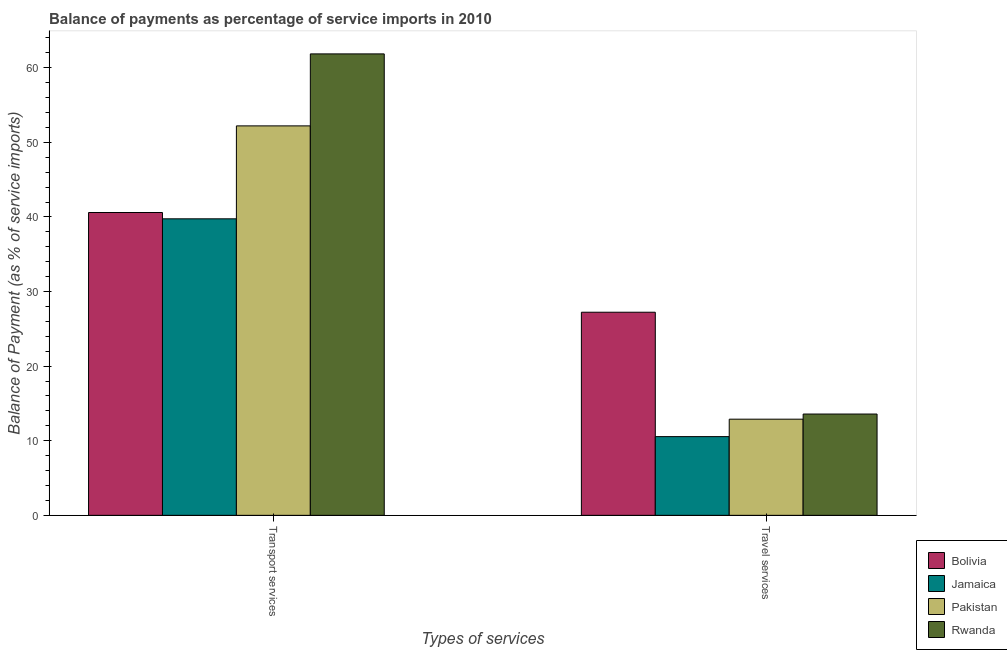Are the number of bars per tick equal to the number of legend labels?
Keep it short and to the point. Yes. How many bars are there on the 1st tick from the right?
Make the answer very short. 4. What is the label of the 2nd group of bars from the left?
Offer a terse response. Travel services. What is the balance of payments of transport services in Pakistan?
Your response must be concise. 52.21. Across all countries, what is the maximum balance of payments of travel services?
Give a very brief answer. 27.23. Across all countries, what is the minimum balance of payments of travel services?
Your response must be concise. 10.55. In which country was the balance of payments of transport services maximum?
Provide a succinct answer. Rwanda. In which country was the balance of payments of transport services minimum?
Ensure brevity in your answer.  Jamaica. What is the total balance of payments of travel services in the graph?
Your answer should be compact. 64.25. What is the difference between the balance of payments of transport services in Rwanda and that in Jamaica?
Keep it short and to the point. 22.11. What is the difference between the balance of payments of transport services in Pakistan and the balance of payments of travel services in Rwanda?
Keep it short and to the point. 38.63. What is the average balance of payments of transport services per country?
Offer a terse response. 48.6. What is the difference between the balance of payments of transport services and balance of payments of travel services in Bolivia?
Make the answer very short. 13.37. In how many countries, is the balance of payments of travel services greater than 2 %?
Your answer should be very brief. 4. What is the ratio of the balance of payments of transport services in Bolivia to that in Rwanda?
Keep it short and to the point. 0.66. In how many countries, is the balance of payments of transport services greater than the average balance of payments of transport services taken over all countries?
Your answer should be compact. 2. What does the 2nd bar from the left in Travel services represents?
Give a very brief answer. Jamaica. Are all the bars in the graph horizontal?
Keep it short and to the point. No. How many countries are there in the graph?
Your answer should be compact. 4. What is the difference between two consecutive major ticks on the Y-axis?
Your answer should be very brief. 10. Does the graph contain grids?
Your answer should be compact. No. Where does the legend appear in the graph?
Give a very brief answer. Bottom right. How many legend labels are there?
Give a very brief answer. 4. What is the title of the graph?
Give a very brief answer. Balance of payments as percentage of service imports in 2010. What is the label or title of the X-axis?
Offer a very short reply. Types of services. What is the label or title of the Y-axis?
Your answer should be compact. Balance of Payment (as % of service imports). What is the Balance of Payment (as % of service imports) in Bolivia in Transport services?
Ensure brevity in your answer.  40.6. What is the Balance of Payment (as % of service imports) in Jamaica in Transport services?
Offer a terse response. 39.75. What is the Balance of Payment (as % of service imports) of Pakistan in Transport services?
Give a very brief answer. 52.21. What is the Balance of Payment (as % of service imports) in Rwanda in Transport services?
Make the answer very short. 61.86. What is the Balance of Payment (as % of service imports) of Bolivia in Travel services?
Provide a short and direct response. 27.23. What is the Balance of Payment (as % of service imports) of Jamaica in Travel services?
Make the answer very short. 10.55. What is the Balance of Payment (as % of service imports) in Pakistan in Travel services?
Make the answer very short. 12.89. What is the Balance of Payment (as % of service imports) in Rwanda in Travel services?
Provide a succinct answer. 13.58. Across all Types of services, what is the maximum Balance of Payment (as % of service imports) of Bolivia?
Give a very brief answer. 40.6. Across all Types of services, what is the maximum Balance of Payment (as % of service imports) of Jamaica?
Give a very brief answer. 39.75. Across all Types of services, what is the maximum Balance of Payment (as % of service imports) in Pakistan?
Provide a short and direct response. 52.21. Across all Types of services, what is the maximum Balance of Payment (as % of service imports) in Rwanda?
Your answer should be very brief. 61.86. Across all Types of services, what is the minimum Balance of Payment (as % of service imports) of Bolivia?
Your answer should be very brief. 27.23. Across all Types of services, what is the minimum Balance of Payment (as % of service imports) in Jamaica?
Make the answer very short. 10.55. Across all Types of services, what is the minimum Balance of Payment (as % of service imports) of Pakistan?
Give a very brief answer. 12.89. Across all Types of services, what is the minimum Balance of Payment (as % of service imports) of Rwanda?
Your answer should be very brief. 13.58. What is the total Balance of Payment (as % of service imports) in Bolivia in the graph?
Give a very brief answer. 67.82. What is the total Balance of Payment (as % of service imports) of Jamaica in the graph?
Provide a short and direct response. 50.3. What is the total Balance of Payment (as % of service imports) of Pakistan in the graph?
Your response must be concise. 65.1. What is the total Balance of Payment (as % of service imports) in Rwanda in the graph?
Your answer should be compact. 75.44. What is the difference between the Balance of Payment (as % of service imports) in Bolivia in Transport services and that in Travel services?
Give a very brief answer. 13.37. What is the difference between the Balance of Payment (as % of service imports) in Jamaica in Transport services and that in Travel services?
Keep it short and to the point. 29.2. What is the difference between the Balance of Payment (as % of service imports) in Pakistan in Transport services and that in Travel services?
Offer a terse response. 39.32. What is the difference between the Balance of Payment (as % of service imports) of Rwanda in Transport services and that in Travel services?
Give a very brief answer. 48.28. What is the difference between the Balance of Payment (as % of service imports) of Bolivia in Transport services and the Balance of Payment (as % of service imports) of Jamaica in Travel services?
Offer a very short reply. 30.04. What is the difference between the Balance of Payment (as % of service imports) in Bolivia in Transport services and the Balance of Payment (as % of service imports) in Pakistan in Travel services?
Make the answer very short. 27.7. What is the difference between the Balance of Payment (as % of service imports) of Bolivia in Transport services and the Balance of Payment (as % of service imports) of Rwanda in Travel services?
Keep it short and to the point. 27.02. What is the difference between the Balance of Payment (as % of service imports) in Jamaica in Transport services and the Balance of Payment (as % of service imports) in Pakistan in Travel services?
Keep it short and to the point. 26.86. What is the difference between the Balance of Payment (as % of service imports) of Jamaica in Transport services and the Balance of Payment (as % of service imports) of Rwanda in Travel services?
Provide a short and direct response. 26.17. What is the difference between the Balance of Payment (as % of service imports) of Pakistan in Transport services and the Balance of Payment (as % of service imports) of Rwanda in Travel services?
Your response must be concise. 38.63. What is the average Balance of Payment (as % of service imports) in Bolivia per Types of services?
Offer a very short reply. 33.91. What is the average Balance of Payment (as % of service imports) in Jamaica per Types of services?
Provide a short and direct response. 25.15. What is the average Balance of Payment (as % of service imports) in Pakistan per Types of services?
Provide a short and direct response. 32.55. What is the average Balance of Payment (as % of service imports) in Rwanda per Types of services?
Keep it short and to the point. 37.72. What is the difference between the Balance of Payment (as % of service imports) of Bolivia and Balance of Payment (as % of service imports) of Jamaica in Transport services?
Offer a very short reply. 0.84. What is the difference between the Balance of Payment (as % of service imports) of Bolivia and Balance of Payment (as % of service imports) of Pakistan in Transport services?
Make the answer very short. -11.61. What is the difference between the Balance of Payment (as % of service imports) of Bolivia and Balance of Payment (as % of service imports) of Rwanda in Transport services?
Your answer should be compact. -21.26. What is the difference between the Balance of Payment (as % of service imports) in Jamaica and Balance of Payment (as % of service imports) in Pakistan in Transport services?
Provide a succinct answer. -12.46. What is the difference between the Balance of Payment (as % of service imports) in Jamaica and Balance of Payment (as % of service imports) in Rwanda in Transport services?
Keep it short and to the point. -22.11. What is the difference between the Balance of Payment (as % of service imports) of Pakistan and Balance of Payment (as % of service imports) of Rwanda in Transport services?
Your response must be concise. -9.65. What is the difference between the Balance of Payment (as % of service imports) in Bolivia and Balance of Payment (as % of service imports) in Jamaica in Travel services?
Your response must be concise. 16.68. What is the difference between the Balance of Payment (as % of service imports) of Bolivia and Balance of Payment (as % of service imports) of Pakistan in Travel services?
Offer a very short reply. 14.34. What is the difference between the Balance of Payment (as % of service imports) in Bolivia and Balance of Payment (as % of service imports) in Rwanda in Travel services?
Provide a short and direct response. 13.65. What is the difference between the Balance of Payment (as % of service imports) of Jamaica and Balance of Payment (as % of service imports) of Pakistan in Travel services?
Your answer should be very brief. -2.34. What is the difference between the Balance of Payment (as % of service imports) of Jamaica and Balance of Payment (as % of service imports) of Rwanda in Travel services?
Give a very brief answer. -3.03. What is the difference between the Balance of Payment (as % of service imports) in Pakistan and Balance of Payment (as % of service imports) in Rwanda in Travel services?
Keep it short and to the point. -0.69. What is the ratio of the Balance of Payment (as % of service imports) in Bolivia in Transport services to that in Travel services?
Your answer should be compact. 1.49. What is the ratio of the Balance of Payment (as % of service imports) in Jamaica in Transport services to that in Travel services?
Your answer should be very brief. 3.77. What is the ratio of the Balance of Payment (as % of service imports) of Pakistan in Transport services to that in Travel services?
Ensure brevity in your answer.  4.05. What is the ratio of the Balance of Payment (as % of service imports) of Rwanda in Transport services to that in Travel services?
Keep it short and to the point. 4.56. What is the difference between the highest and the second highest Balance of Payment (as % of service imports) of Bolivia?
Ensure brevity in your answer.  13.37. What is the difference between the highest and the second highest Balance of Payment (as % of service imports) in Jamaica?
Your answer should be compact. 29.2. What is the difference between the highest and the second highest Balance of Payment (as % of service imports) of Pakistan?
Make the answer very short. 39.32. What is the difference between the highest and the second highest Balance of Payment (as % of service imports) in Rwanda?
Make the answer very short. 48.28. What is the difference between the highest and the lowest Balance of Payment (as % of service imports) in Bolivia?
Give a very brief answer. 13.37. What is the difference between the highest and the lowest Balance of Payment (as % of service imports) of Jamaica?
Ensure brevity in your answer.  29.2. What is the difference between the highest and the lowest Balance of Payment (as % of service imports) in Pakistan?
Keep it short and to the point. 39.32. What is the difference between the highest and the lowest Balance of Payment (as % of service imports) of Rwanda?
Ensure brevity in your answer.  48.28. 